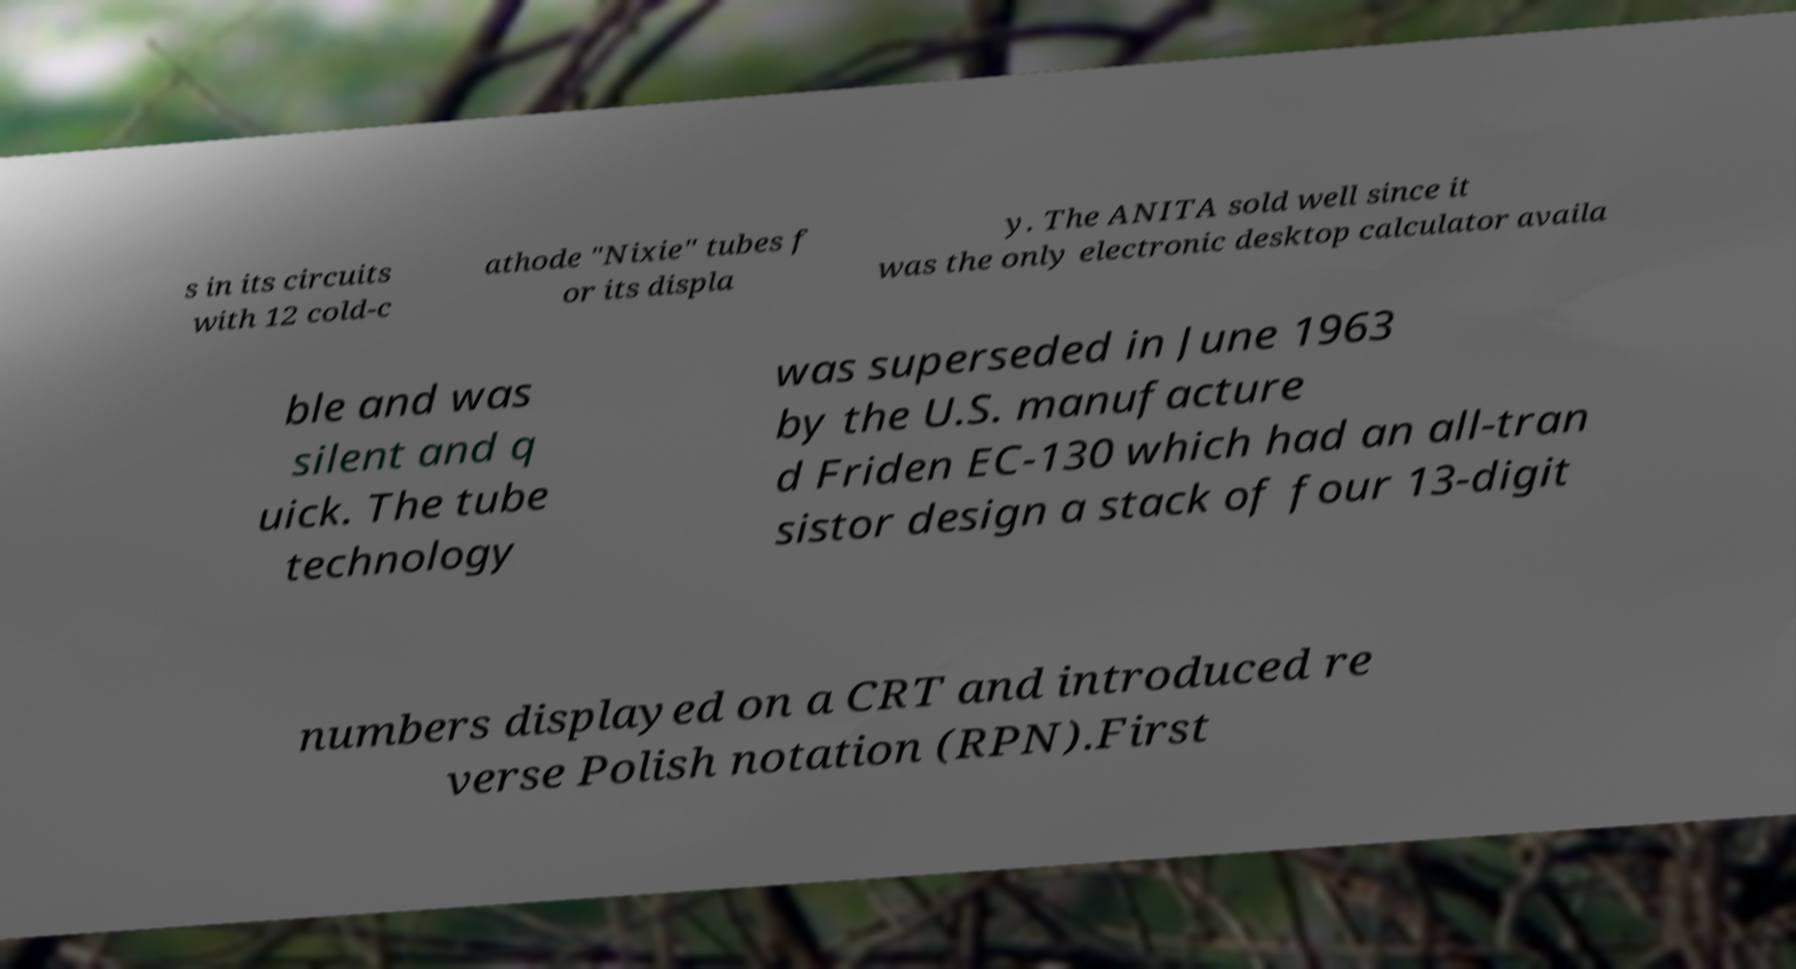I need the written content from this picture converted into text. Can you do that? s in its circuits with 12 cold-c athode "Nixie" tubes f or its displa y. The ANITA sold well since it was the only electronic desktop calculator availa ble and was silent and q uick. The tube technology was superseded in June 1963 by the U.S. manufacture d Friden EC-130 which had an all-tran sistor design a stack of four 13-digit numbers displayed on a CRT and introduced re verse Polish notation (RPN).First 